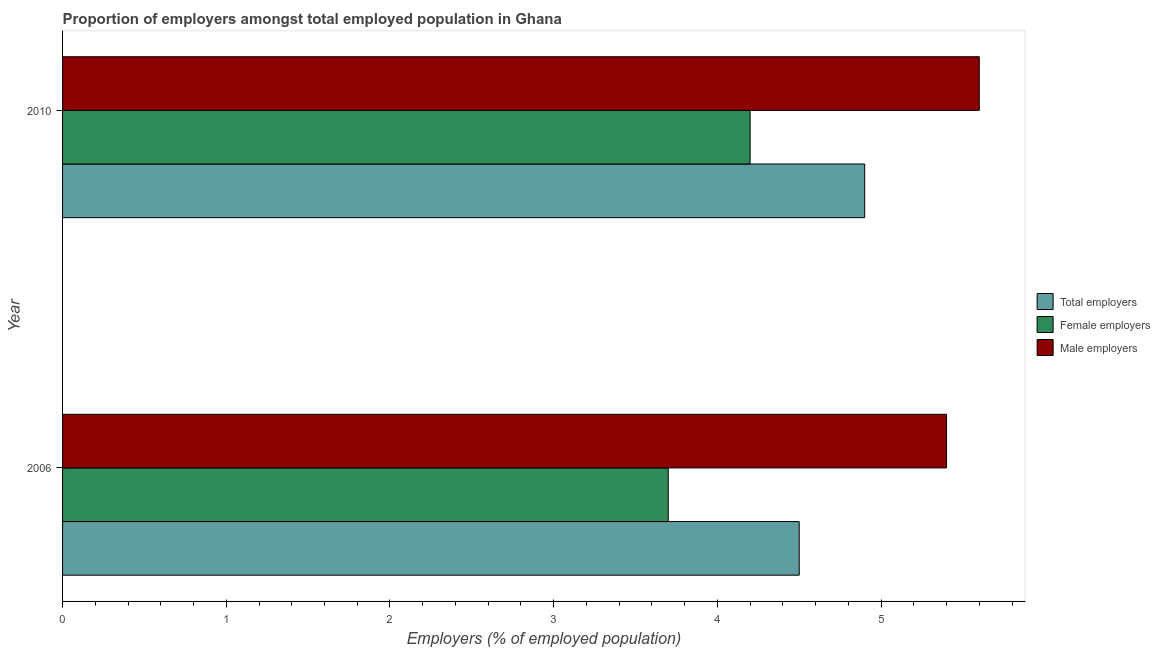Are the number of bars on each tick of the Y-axis equal?
Offer a very short reply. Yes. How many bars are there on the 1st tick from the bottom?
Provide a succinct answer. 3. Across all years, what is the maximum percentage of male employers?
Your response must be concise. 5.6. Across all years, what is the minimum percentage of female employers?
Offer a very short reply. 3.7. What is the total percentage of total employers in the graph?
Offer a very short reply. 9.4. What is the difference between the percentage of female employers in 2006 and that in 2010?
Make the answer very short. -0.5. What is the difference between the percentage of male employers in 2006 and the percentage of total employers in 2010?
Your answer should be compact. 0.5. What is the average percentage of female employers per year?
Make the answer very short. 3.95. What is the ratio of the percentage of female employers in 2006 to that in 2010?
Provide a succinct answer. 0.88. Is the percentage of male employers in 2006 less than that in 2010?
Your answer should be very brief. Yes. What does the 2nd bar from the top in 2006 represents?
Give a very brief answer. Female employers. What does the 2nd bar from the bottom in 2010 represents?
Offer a terse response. Female employers. How many bars are there?
Ensure brevity in your answer.  6. How many years are there in the graph?
Your answer should be compact. 2. What is the difference between two consecutive major ticks on the X-axis?
Provide a succinct answer. 1. Where does the legend appear in the graph?
Give a very brief answer. Center right. How many legend labels are there?
Provide a short and direct response. 3. What is the title of the graph?
Your answer should be very brief. Proportion of employers amongst total employed population in Ghana. Does "Wage workers" appear as one of the legend labels in the graph?
Offer a terse response. No. What is the label or title of the X-axis?
Ensure brevity in your answer.  Employers (% of employed population). What is the label or title of the Y-axis?
Make the answer very short. Year. What is the Employers (% of employed population) of Total employers in 2006?
Your answer should be compact. 4.5. What is the Employers (% of employed population) of Female employers in 2006?
Keep it short and to the point. 3.7. What is the Employers (% of employed population) of Male employers in 2006?
Your answer should be very brief. 5.4. What is the Employers (% of employed population) in Total employers in 2010?
Your answer should be very brief. 4.9. What is the Employers (% of employed population) in Female employers in 2010?
Offer a very short reply. 4.2. What is the Employers (% of employed population) in Male employers in 2010?
Your response must be concise. 5.6. Across all years, what is the maximum Employers (% of employed population) in Total employers?
Give a very brief answer. 4.9. Across all years, what is the maximum Employers (% of employed population) of Female employers?
Make the answer very short. 4.2. Across all years, what is the maximum Employers (% of employed population) in Male employers?
Your response must be concise. 5.6. Across all years, what is the minimum Employers (% of employed population) in Total employers?
Provide a short and direct response. 4.5. Across all years, what is the minimum Employers (% of employed population) of Female employers?
Offer a very short reply. 3.7. Across all years, what is the minimum Employers (% of employed population) in Male employers?
Keep it short and to the point. 5.4. What is the total Employers (% of employed population) of Total employers in the graph?
Your response must be concise. 9.4. What is the total Employers (% of employed population) in Male employers in the graph?
Your answer should be very brief. 11. What is the difference between the Employers (% of employed population) in Female employers in 2006 and that in 2010?
Your answer should be compact. -0.5. What is the difference between the Employers (% of employed population) of Female employers in 2006 and the Employers (% of employed population) of Male employers in 2010?
Your answer should be compact. -1.9. What is the average Employers (% of employed population) of Total employers per year?
Offer a very short reply. 4.7. What is the average Employers (% of employed population) of Female employers per year?
Provide a short and direct response. 3.95. What is the average Employers (% of employed population) in Male employers per year?
Ensure brevity in your answer.  5.5. In the year 2010, what is the difference between the Employers (% of employed population) in Total employers and Employers (% of employed population) in Female employers?
Offer a terse response. 0.7. In the year 2010, what is the difference between the Employers (% of employed population) in Female employers and Employers (% of employed population) in Male employers?
Make the answer very short. -1.4. What is the ratio of the Employers (% of employed population) in Total employers in 2006 to that in 2010?
Keep it short and to the point. 0.92. What is the ratio of the Employers (% of employed population) of Female employers in 2006 to that in 2010?
Provide a short and direct response. 0.88. What is the ratio of the Employers (% of employed population) in Male employers in 2006 to that in 2010?
Provide a short and direct response. 0.96. What is the difference between the highest and the second highest Employers (% of employed population) of Total employers?
Offer a terse response. 0.4. What is the difference between the highest and the second highest Employers (% of employed population) of Female employers?
Your answer should be very brief. 0.5. What is the difference between the highest and the second highest Employers (% of employed population) in Male employers?
Your answer should be compact. 0.2. What is the difference between the highest and the lowest Employers (% of employed population) in Total employers?
Your answer should be very brief. 0.4. What is the difference between the highest and the lowest Employers (% of employed population) in Female employers?
Your response must be concise. 0.5. 